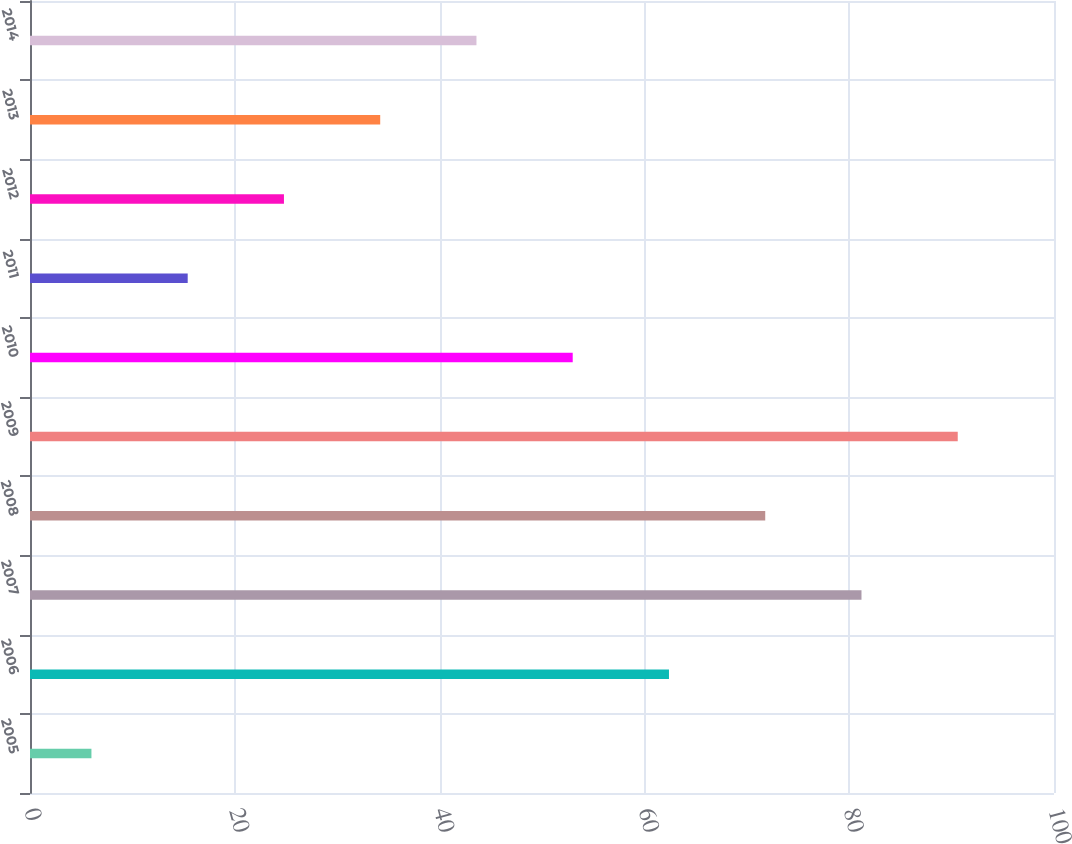Convert chart. <chart><loc_0><loc_0><loc_500><loc_500><bar_chart><fcel>2005<fcel>2006<fcel>2007<fcel>2008<fcel>2009<fcel>2010<fcel>2011<fcel>2012<fcel>2013<fcel>2014<nl><fcel>6<fcel>62.4<fcel>81.2<fcel>71.8<fcel>90.6<fcel>53<fcel>15.4<fcel>24.8<fcel>34.2<fcel>43.6<nl></chart> 